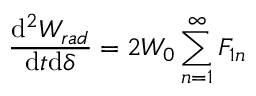<formula> <loc_0><loc_0><loc_500><loc_500>\frac { d ^ { 2 } W _ { r a d } } { d t d \delta } = 2 W _ { 0 } \sum _ { n = 1 } ^ { \infty } F _ { 1 n }</formula> 